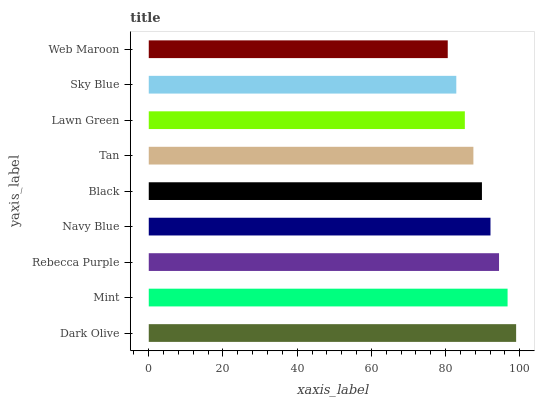Is Web Maroon the minimum?
Answer yes or no. Yes. Is Dark Olive the maximum?
Answer yes or no. Yes. Is Mint the minimum?
Answer yes or no. No. Is Mint the maximum?
Answer yes or no. No. Is Dark Olive greater than Mint?
Answer yes or no. Yes. Is Mint less than Dark Olive?
Answer yes or no. Yes. Is Mint greater than Dark Olive?
Answer yes or no. No. Is Dark Olive less than Mint?
Answer yes or no. No. Is Black the high median?
Answer yes or no. Yes. Is Black the low median?
Answer yes or no. Yes. Is Mint the high median?
Answer yes or no. No. Is Web Maroon the low median?
Answer yes or no. No. 